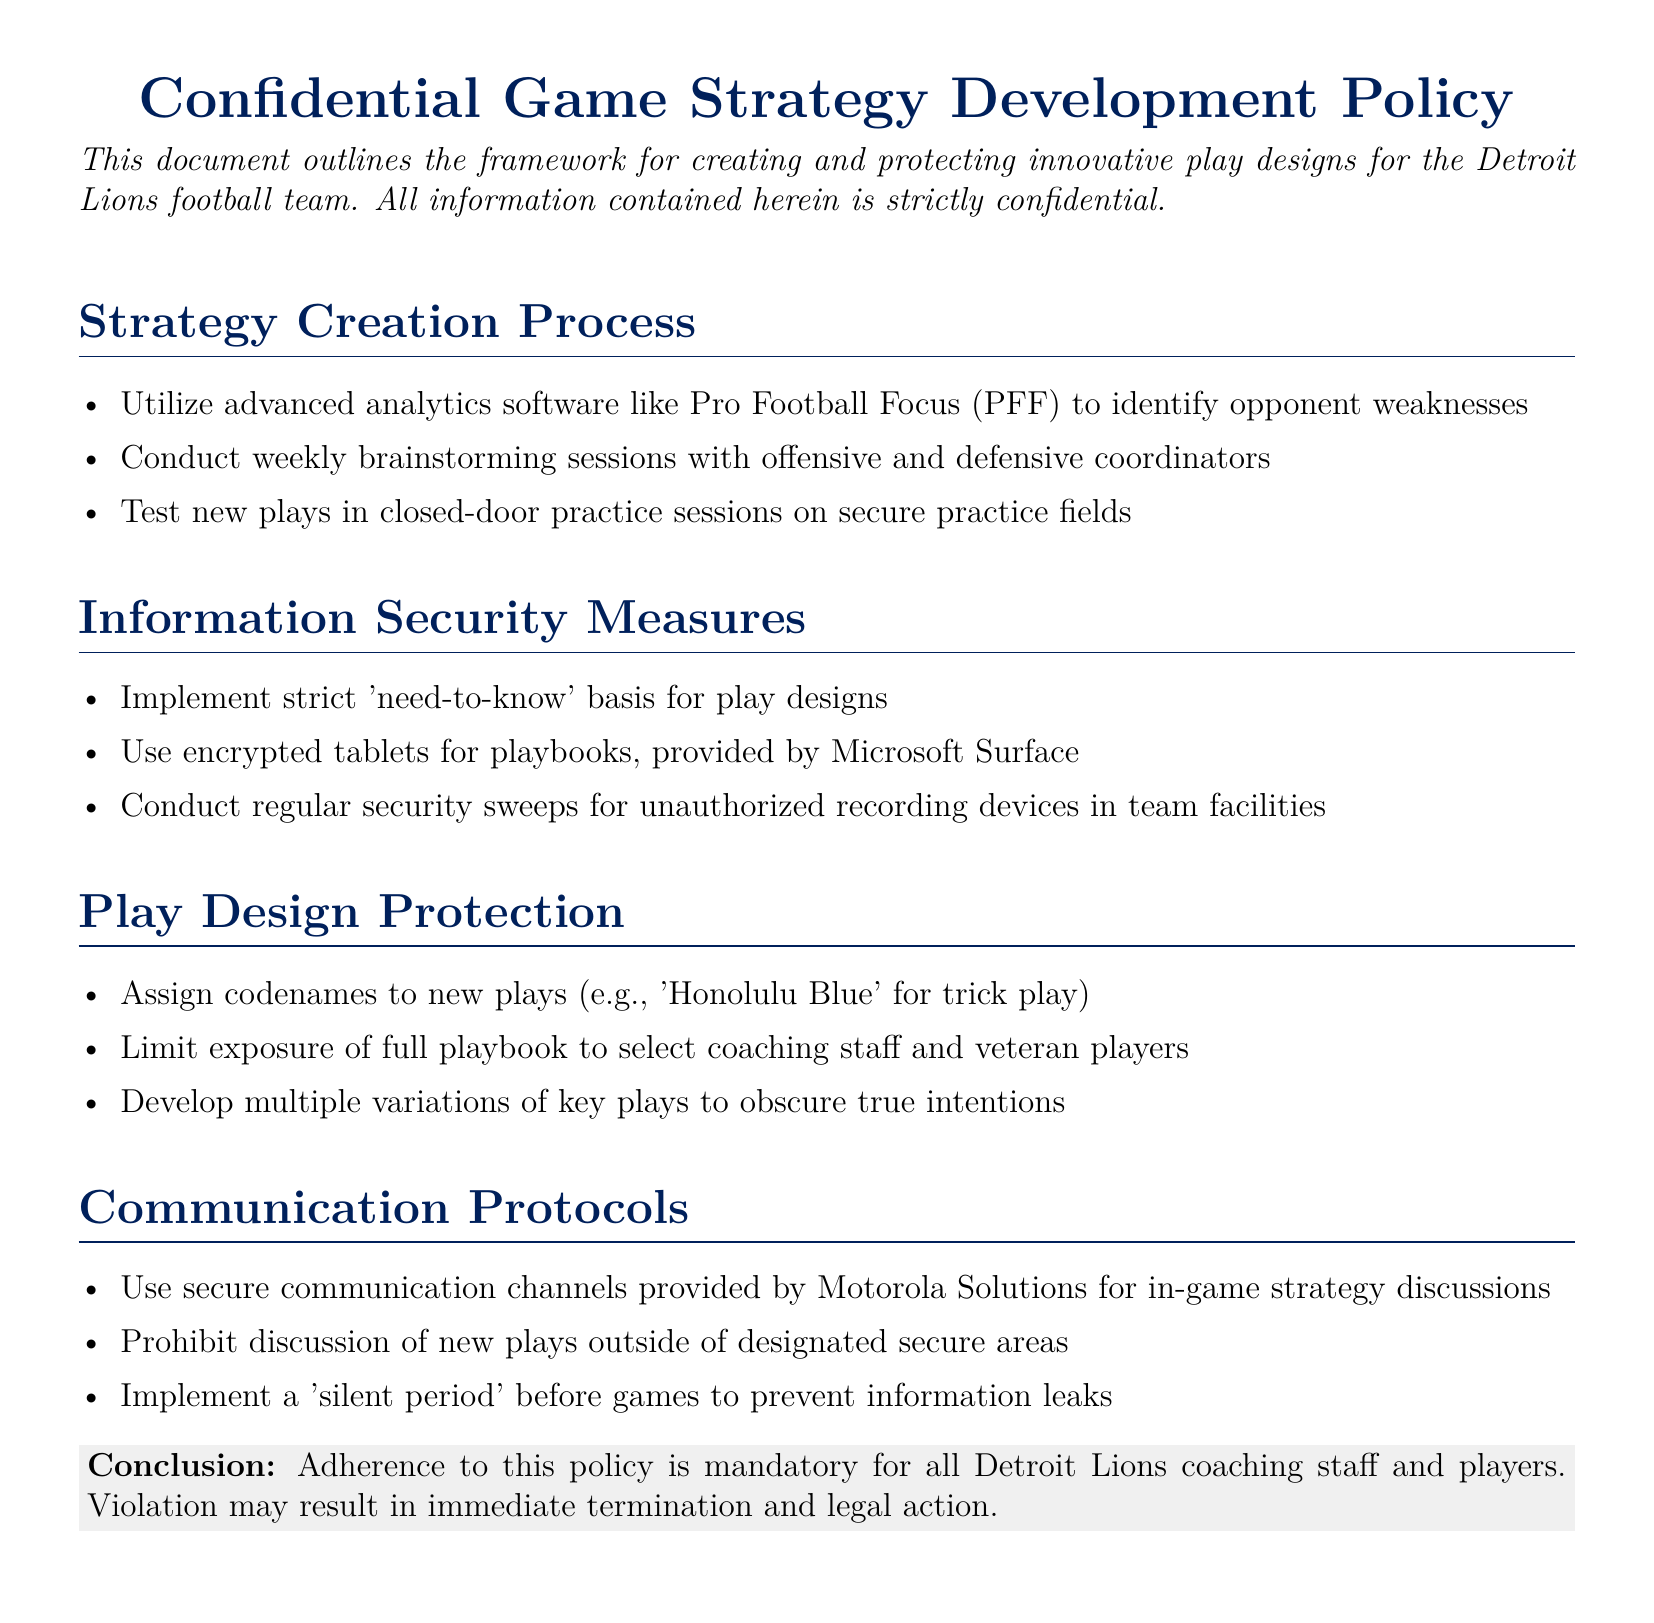What is the purpose of this document? The document outlines the framework for creating and protecting innovative play designs for the Detroit Lions football team.
Answer: framework for creating and protecting innovative play designs What analytics software is mentioned? The document mentions advanced analytics software used to identify opponent weaknesses.
Answer: Pro Football Focus What is one method for protecting play designs? The document lists specific measures to protect play designs against unauthorized access.
Answer: Assign codenames Which tablets are used for playbooks? The document specifies the type of tablets provided to the team for security purposes.
Answer: Microsoft Surface What is the consequence of violating the policy? The document outlines the repercussions for any violation of the stated policy.
Answer: immediate termination and legal action What type of sessions are conducted weekly? The document mentions collaborative discussions that take place weekly among coaching staff.
Answer: brainstorming sessions What term describes the communication channels for in-game discussions? The document refers to specific secure channels for discussing strategies during games.
Answer: secure communication channels What is implemented before games to prevent leaks? The document outlines a protocol aimed at preventing information leaks prior to games.
Answer: silent period What color-coded paper is used for the conclusion? The document describes a specific color used for a highlighted section summarizing the policy.
Answer: light gray 